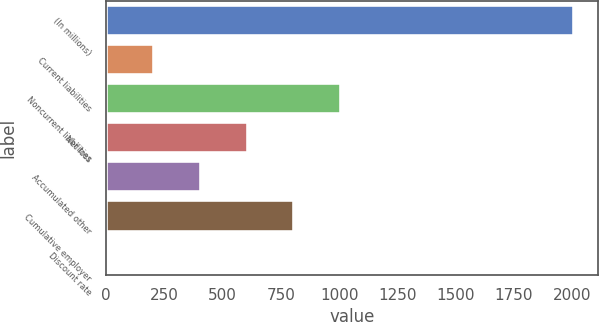<chart> <loc_0><loc_0><loc_500><loc_500><bar_chart><fcel>(In millions)<fcel>Current liabilities<fcel>Noncurrent liabilities<fcel>Net loss<fcel>Accumulated other<fcel>Cumulative employer<fcel>Discount rate<nl><fcel>2009<fcel>206.3<fcel>1007.5<fcel>606.9<fcel>406.6<fcel>807.2<fcel>6<nl></chart> 